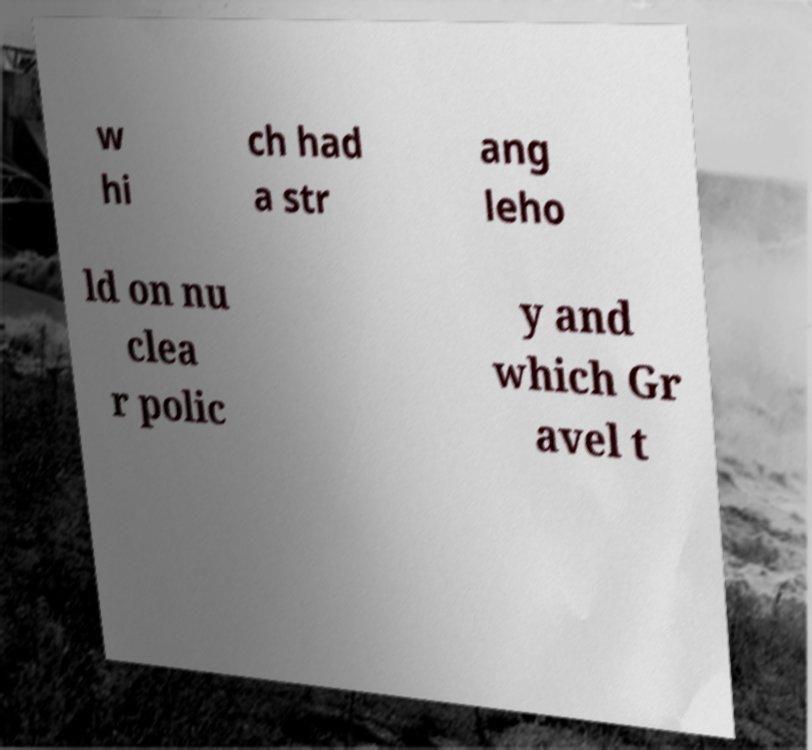I need the written content from this picture converted into text. Can you do that? w hi ch had a str ang leho ld on nu clea r polic y and which Gr avel t 